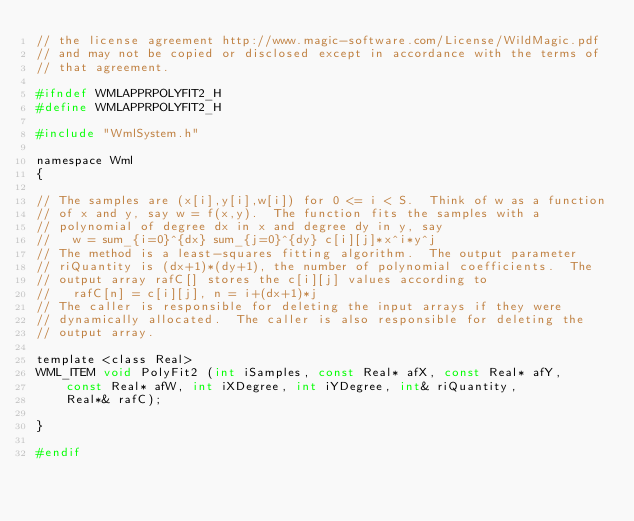Convert code to text. <code><loc_0><loc_0><loc_500><loc_500><_C_>// the license agreement http://www.magic-software.com/License/WildMagic.pdf
// and may not be copied or disclosed except in accordance with the terms of
// that agreement.

#ifndef WMLAPPRPOLYFIT2_H
#define WMLAPPRPOLYFIT2_H

#include "WmlSystem.h"

namespace Wml
{

// The samples are (x[i],y[i],w[i]) for 0 <= i < S.  Think of w as a function
// of x and y, say w = f(x,y).  The function fits the samples with a
// polynomial of degree dx in x and degree dy in y, say
//   w = sum_{i=0}^{dx} sum_{j=0}^{dy} c[i][j]*x^i*y^j
// The method is a least-squares fitting algorithm.  The output parameter
// riQuantity is (dx+1)*(dy+1), the number of polynomial coefficients.  The
// output array rafC[] stores the c[i][j] values according to
//   rafC[n] = c[i][j], n = i+(dx+1)*j
// The caller is responsible for deleting the input arrays if they were
// dynamically allocated.  The caller is also responsible for deleting the
// output array.

template <class Real>
WML_ITEM void PolyFit2 (int iSamples, const Real* afX, const Real* afY,
    const Real* afW, int iXDegree, int iYDegree, int& riQuantity,
    Real*& rafC);

}

#endif
</code> 